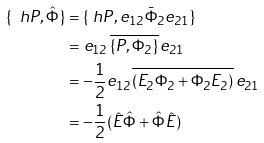Convert formula to latex. <formula><loc_0><loc_0><loc_500><loc_500>\{ \ h P , \hat { \Phi } \} & = \{ \ h P , e _ { 1 2 } \bar { \Phi } _ { 2 } e _ { 2 1 } \} \\ & = e _ { 1 2 } \, \overline { \{ P , \Phi _ { 2 } \} } \, e _ { 2 1 } \\ & = - \frac { 1 } { 2 } e _ { 1 2 } \overline { ( E _ { 2 } \Phi _ { 2 } + \Phi _ { 2 } E _ { 2 } ) \strut } \, e _ { 2 1 } \\ & = - \frac { 1 } { 2 } ( \hat { E } \hat { \Phi } + \hat { \Phi } \hat { E } )</formula> 